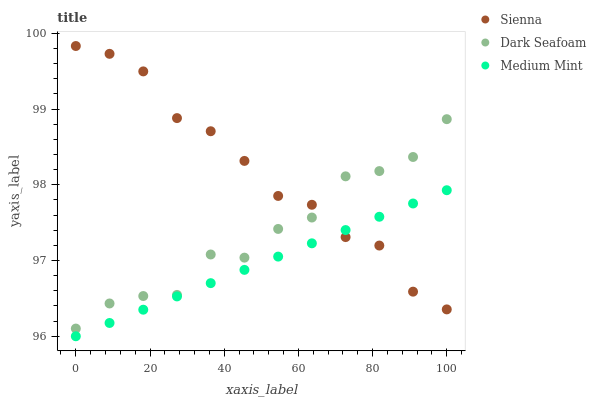Does Medium Mint have the minimum area under the curve?
Answer yes or no. Yes. Does Sienna have the maximum area under the curve?
Answer yes or no. Yes. Does Dark Seafoam have the minimum area under the curve?
Answer yes or no. No. Does Dark Seafoam have the maximum area under the curve?
Answer yes or no. No. Is Medium Mint the smoothest?
Answer yes or no. Yes. Is Dark Seafoam the roughest?
Answer yes or no. Yes. Is Dark Seafoam the smoothest?
Answer yes or no. No. Is Medium Mint the roughest?
Answer yes or no. No. Does Medium Mint have the lowest value?
Answer yes or no. Yes. Does Dark Seafoam have the lowest value?
Answer yes or no. No. Does Sienna have the highest value?
Answer yes or no. Yes. Does Dark Seafoam have the highest value?
Answer yes or no. No. Is Medium Mint less than Dark Seafoam?
Answer yes or no. Yes. Is Dark Seafoam greater than Medium Mint?
Answer yes or no. Yes. Does Sienna intersect Dark Seafoam?
Answer yes or no. Yes. Is Sienna less than Dark Seafoam?
Answer yes or no. No. Is Sienna greater than Dark Seafoam?
Answer yes or no. No. Does Medium Mint intersect Dark Seafoam?
Answer yes or no. No. 